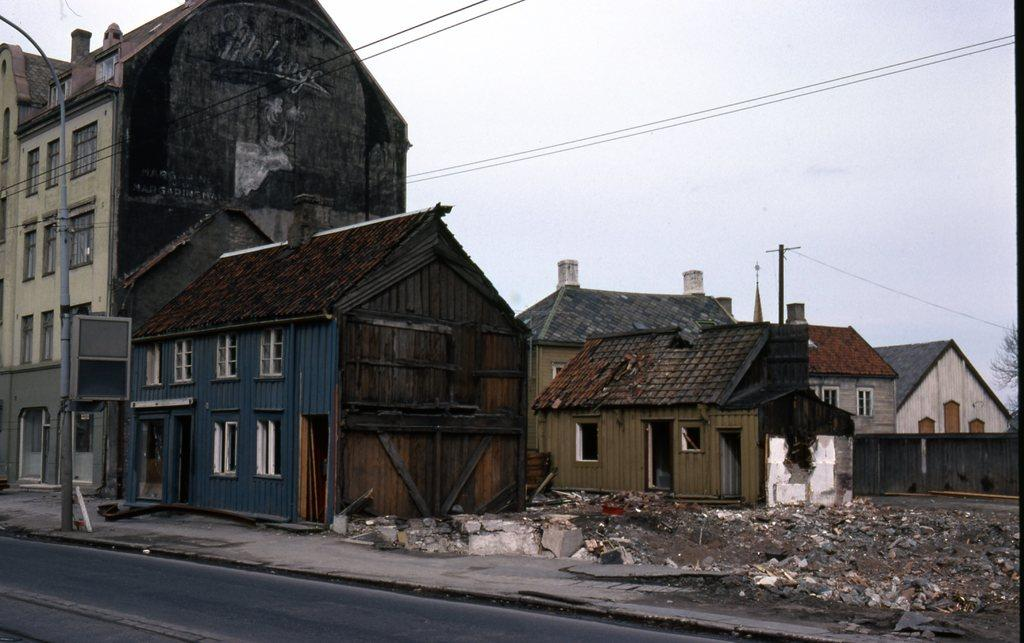What type of structures can be seen in the image? There are houses in the image. What features are present on the houses? There are doors and windows in the image. What other objects can be seen in the image? There are wires, poles, and a tree in the image. What is visible in the background of the image? The sky is visible in the image. How many kittens are playing with the rabbits in the image? There are no kittens or rabbits present in the image. 